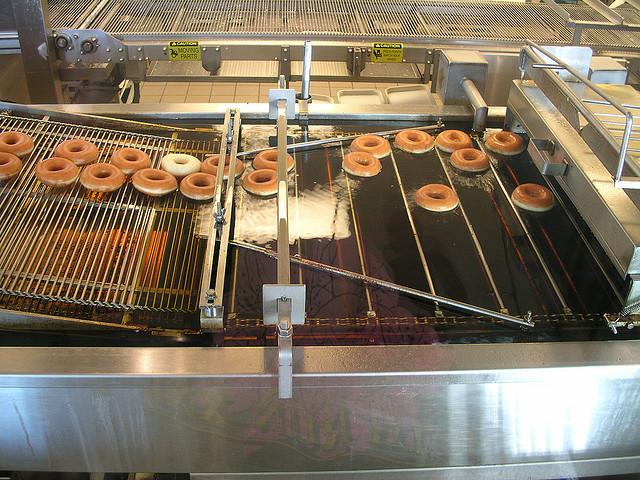What is this type of cooking called? Please explain your reasoning. production line. It has machinery that moves the food through different processes with little human intervention 